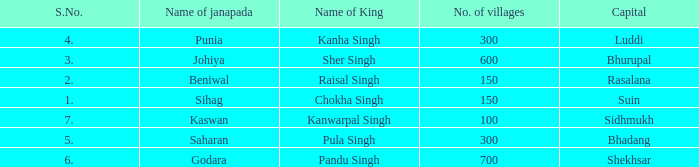What is the average number of villages with a name of janapada of Punia? 300.0. 